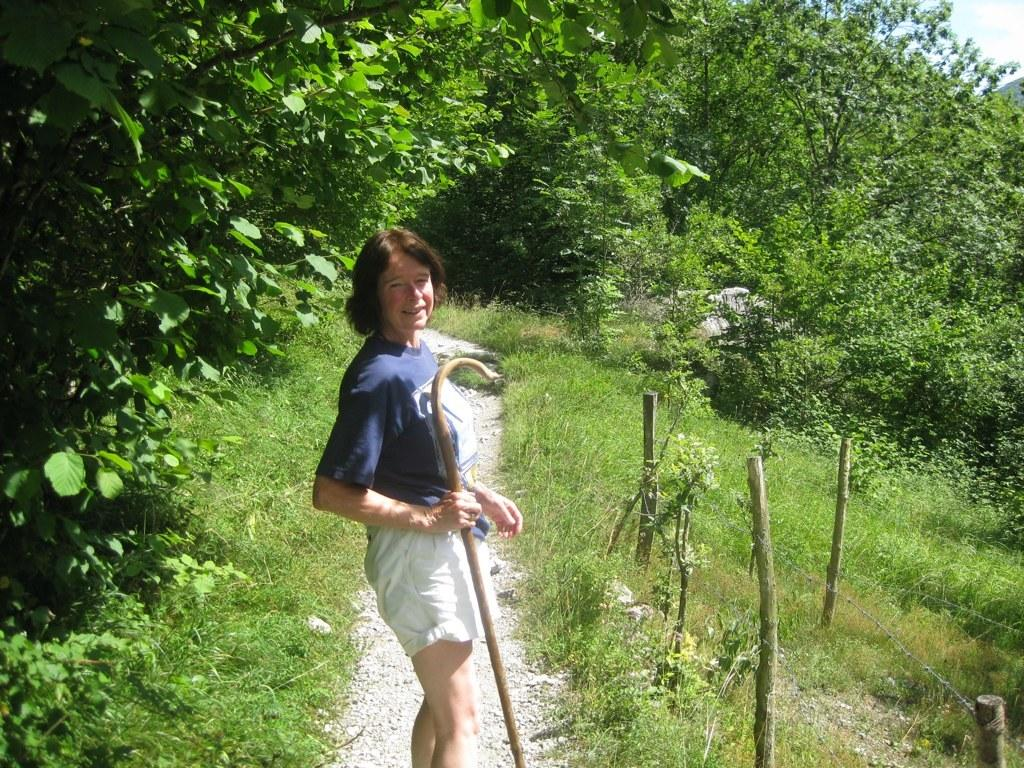Who is the main subject in the image? There is a woman in the image. What is the setting of the image? The woman is standing in between grass. What type of vegetation is present in the image? There are many trees in the image. What is the woman holding in her hand? The woman is holding a wooden stick in her hand. What type of sugar can be seen on the kitten's fur in the image? There is no kitten or sugar present in the image. How does the bubble affect the woman's appearance in the image? There is no bubble present in the image, so it does not affect the woman's appearance. 